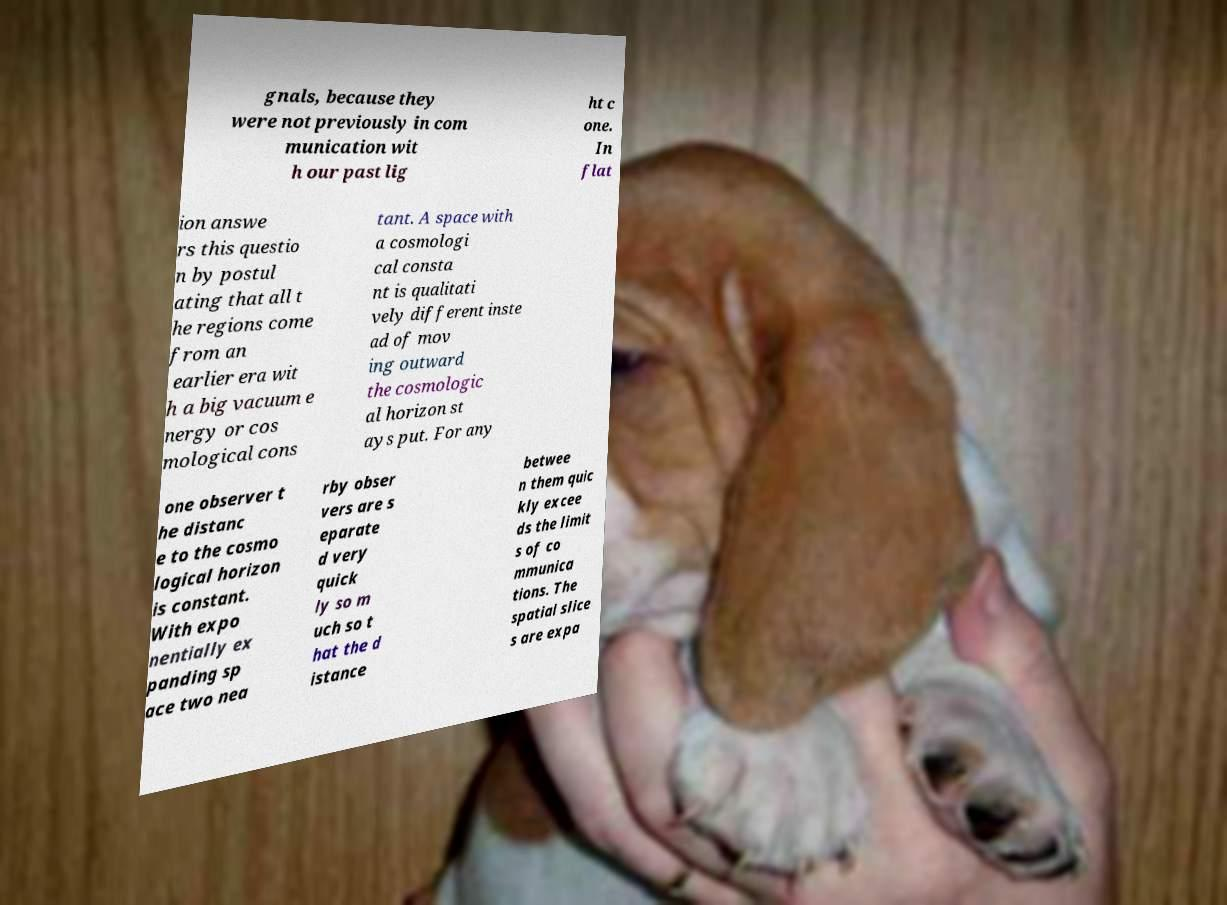Could you extract and type out the text from this image? gnals, because they were not previously in com munication wit h our past lig ht c one. In flat ion answe rs this questio n by postul ating that all t he regions come from an earlier era wit h a big vacuum e nergy or cos mological cons tant. A space with a cosmologi cal consta nt is qualitati vely different inste ad of mov ing outward the cosmologic al horizon st ays put. For any one observer t he distanc e to the cosmo logical horizon is constant. With expo nentially ex panding sp ace two nea rby obser vers are s eparate d very quick ly so m uch so t hat the d istance betwee n them quic kly excee ds the limit s of co mmunica tions. The spatial slice s are expa 